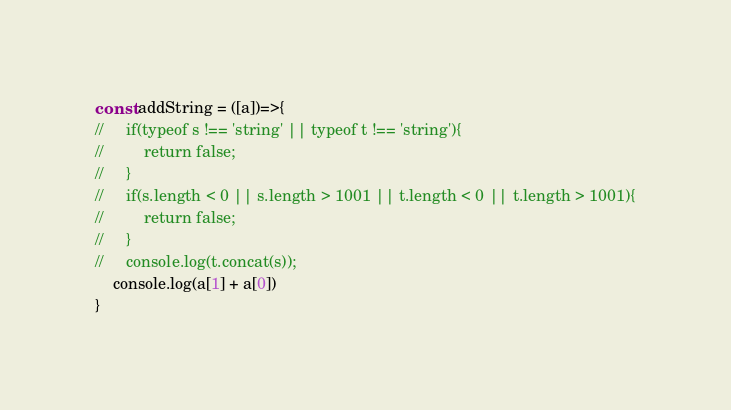<code> <loc_0><loc_0><loc_500><loc_500><_JavaScript_>const addString = ([a])=>{
//     if(typeof s !== 'string' || typeof t !== 'string'){
//         return false;
//     }
//     if(s.length < 0 || s.length > 1001 || t.length < 0 || t.length > 1001){
//         return false;
//     }
//     console.log(t.concat(s));
    console.log(a[1] + a[0])
}</code> 